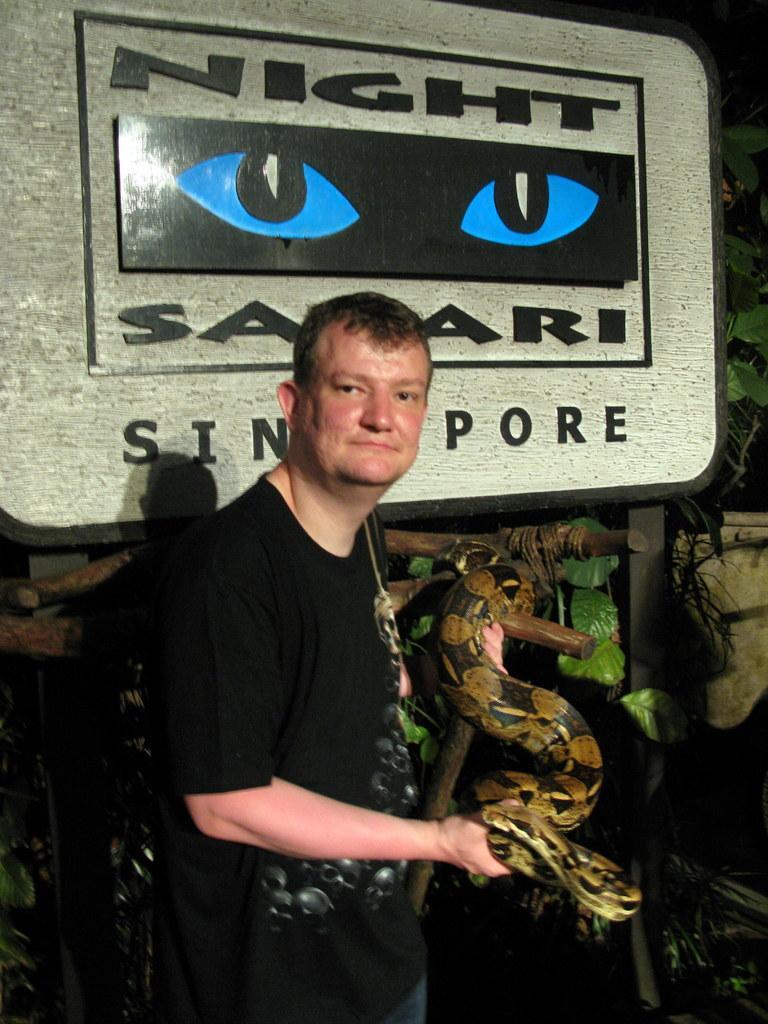In one or two sentences, can you explain what this image depicts? a person is standing wearing a black t shirt, holding a snake in his hand. behind him there is a board on which night safari Singapore is written. behind that there are plants. 